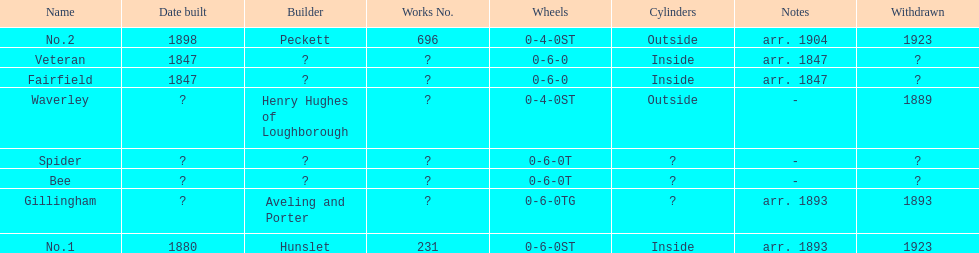Which have known built dates? Veteran, Fairfield, No.1, No.2. What other was built in 1847? Veteran. 